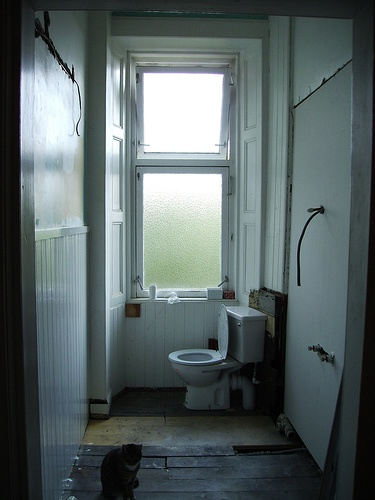Describe the objects in this image and their specific colors. I can see toilet in black, gray, and purple tones and cat in black, gray, darkblue, and purple tones in this image. 